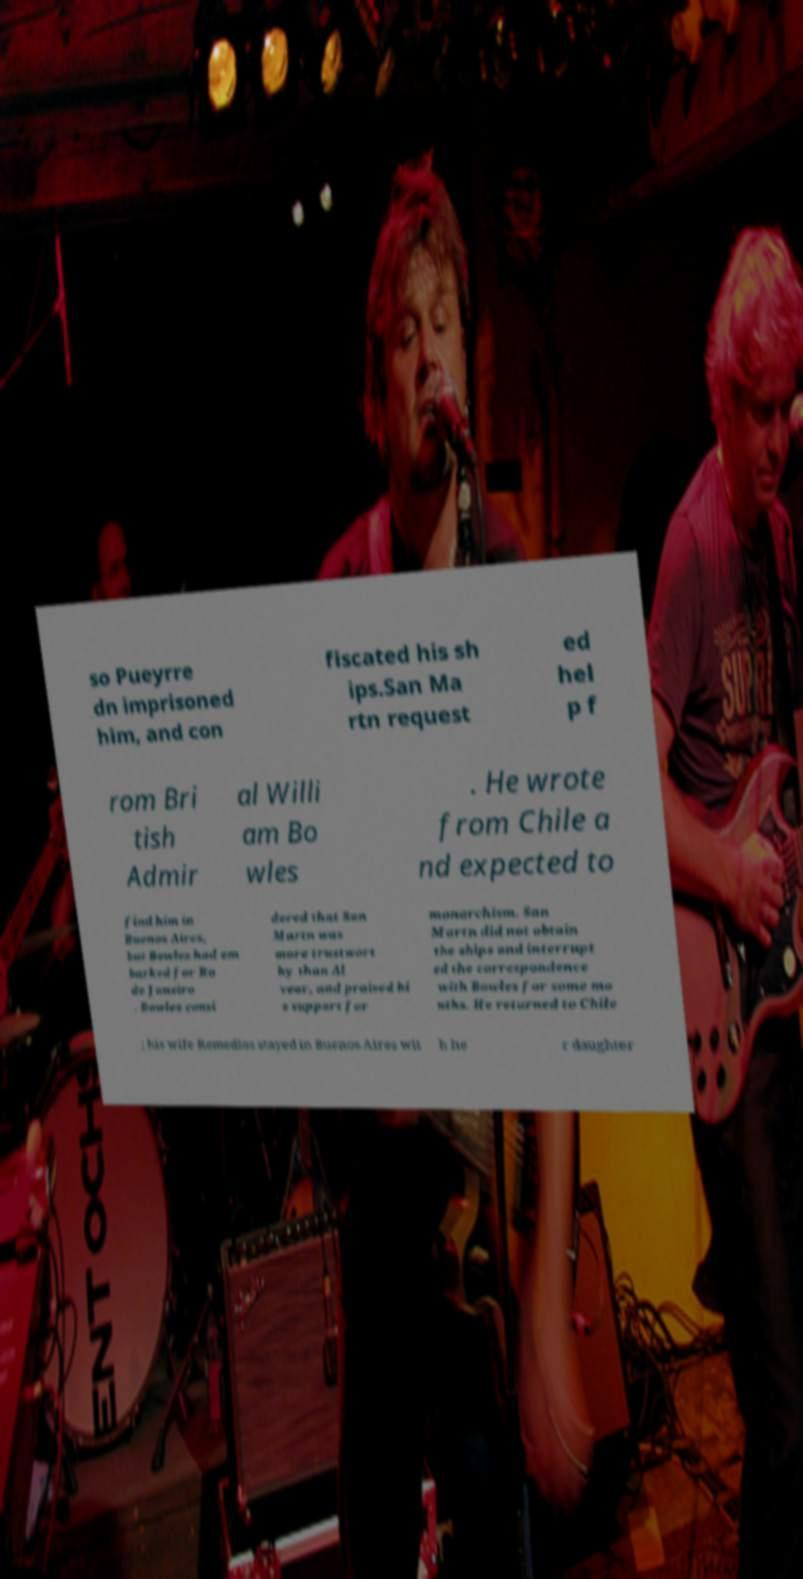Could you extract and type out the text from this image? so Pueyrre dn imprisoned him, and con fiscated his sh ips.San Ma rtn request ed hel p f rom Bri tish Admir al Willi am Bo wles . He wrote from Chile a nd expected to find him in Buenos Aires, but Bowles had em barked for Ro de Janeiro . Bowles consi dered that San Martn was more trustwort hy than Al vear, and praised hi s support for monarchism. San Martn did not obtain the ships and interrupt ed the correspondence with Bowles for some mo nths. He returned to Chile ; his wife Remedios stayed in Buenos Aires wit h he r daughter 